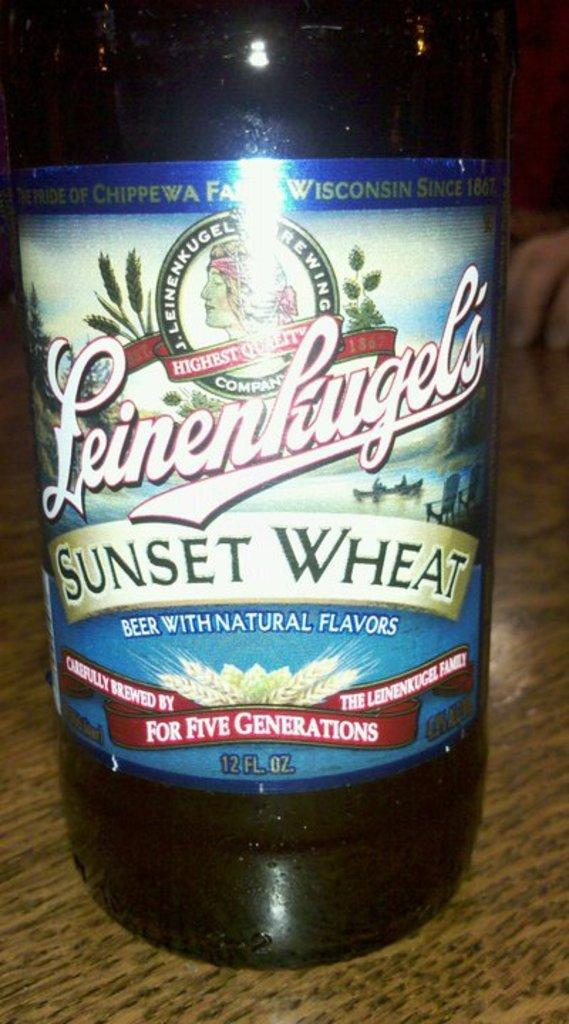<image>
Provide a brief description of the given image. the words sunset wheat that are on a bottle 